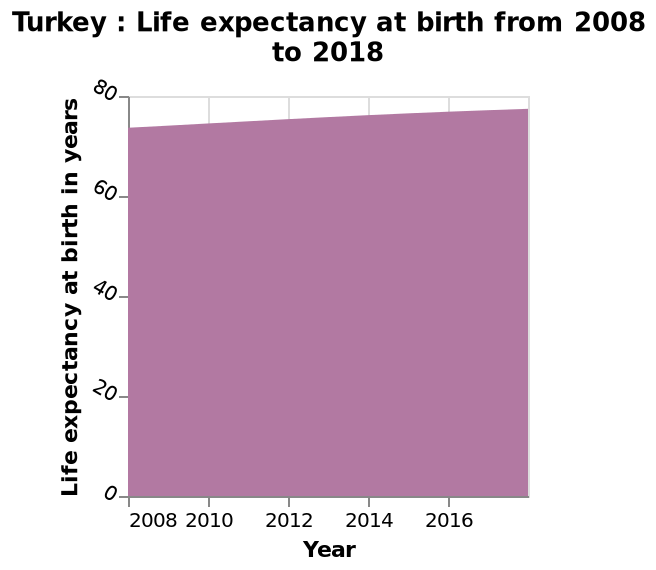<image>
What was the life expectancy in 2008? The life expectancy in 2008 was approximately 75. What is the overall trend of the life expectancy at birth in Turkey from 2008 to 2018?  The overall trend of the life expectancy at birth in Turkey from 2008 to 2018 can be observed by analyzing the area plot. 